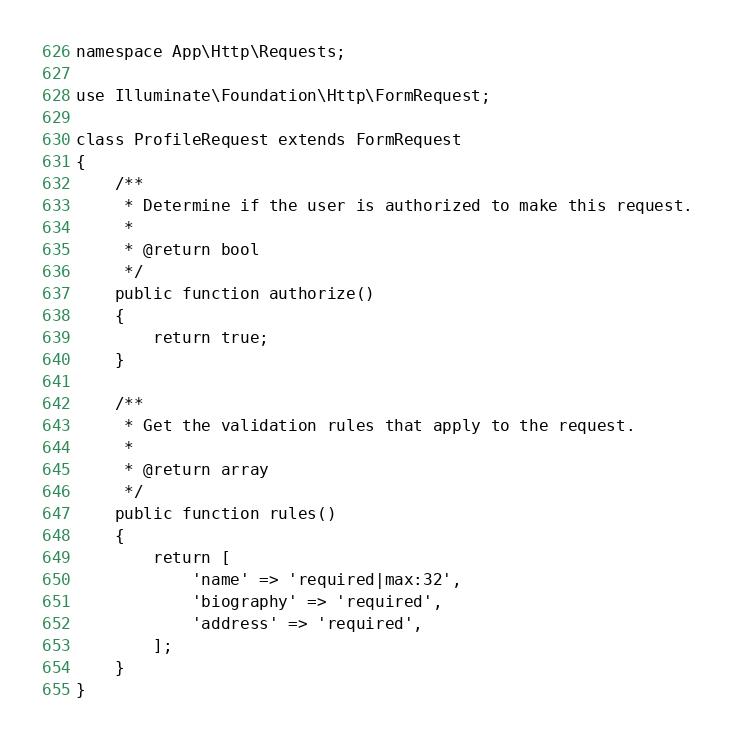<code> <loc_0><loc_0><loc_500><loc_500><_PHP_>
namespace App\Http\Requests;

use Illuminate\Foundation\Http\FormRequest;

class ProfileRequest extends FormRequest
{
    /**
     * Determine if the user is authorized to make this request.
     *
     * @return bool
     */
    public function authorize()
    {
        return true;
    }

    /**
     * Get the validation rules that apply to the request.
     *
     * @return array
     */
    public function rules()
    {
        return [
            'name' => 'required|max:32',
            'biography' => 'required',
            'address' => 'required',
        ];
    }
}
</code> 